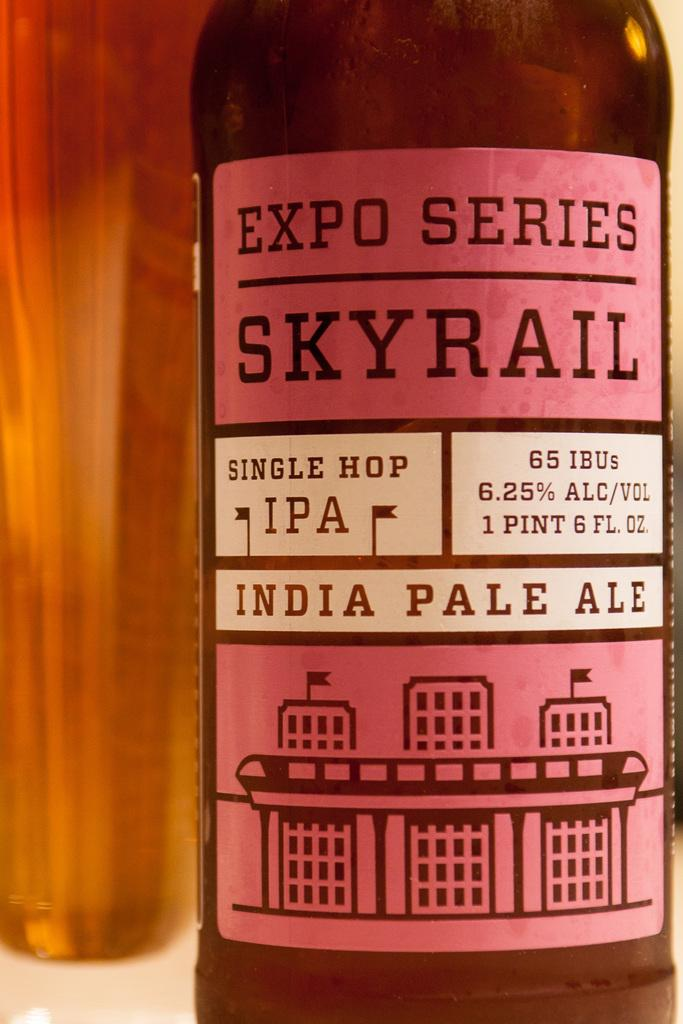<image>
Present a compact description of the photo's key features. The bottle of Expo Series Skyrail India Pale Ale is a single hop IPA bottled in brown glass with a pink and white label. 